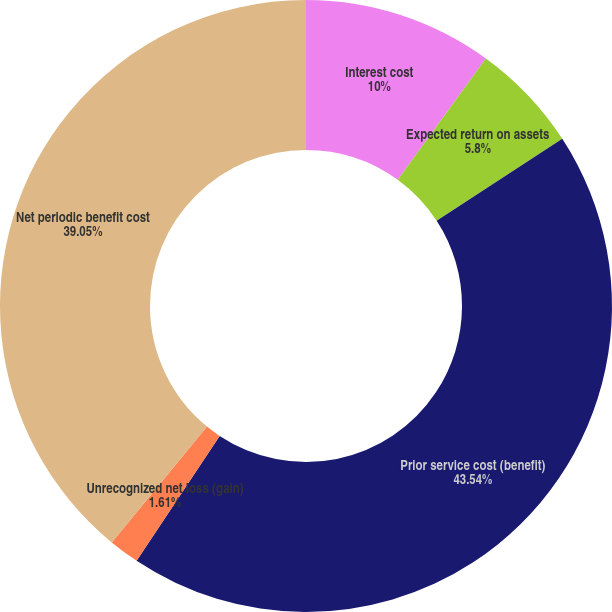Convert chart to OTSL. <chart><loc_0><loc_0><loc_500><loc_500><pie_chart><fcel>Interest cost<fcel>Expected return on assets<fcel>Prior service cost (benefit)<fcel>Unrecognized net loss (gain)<fcel>Net periodic benefit cost<nl><fcel>10.0%<fcel>5.8%<fcel>43.53%<fcel>1.61%<fcel>39.05%<nl></chart> 